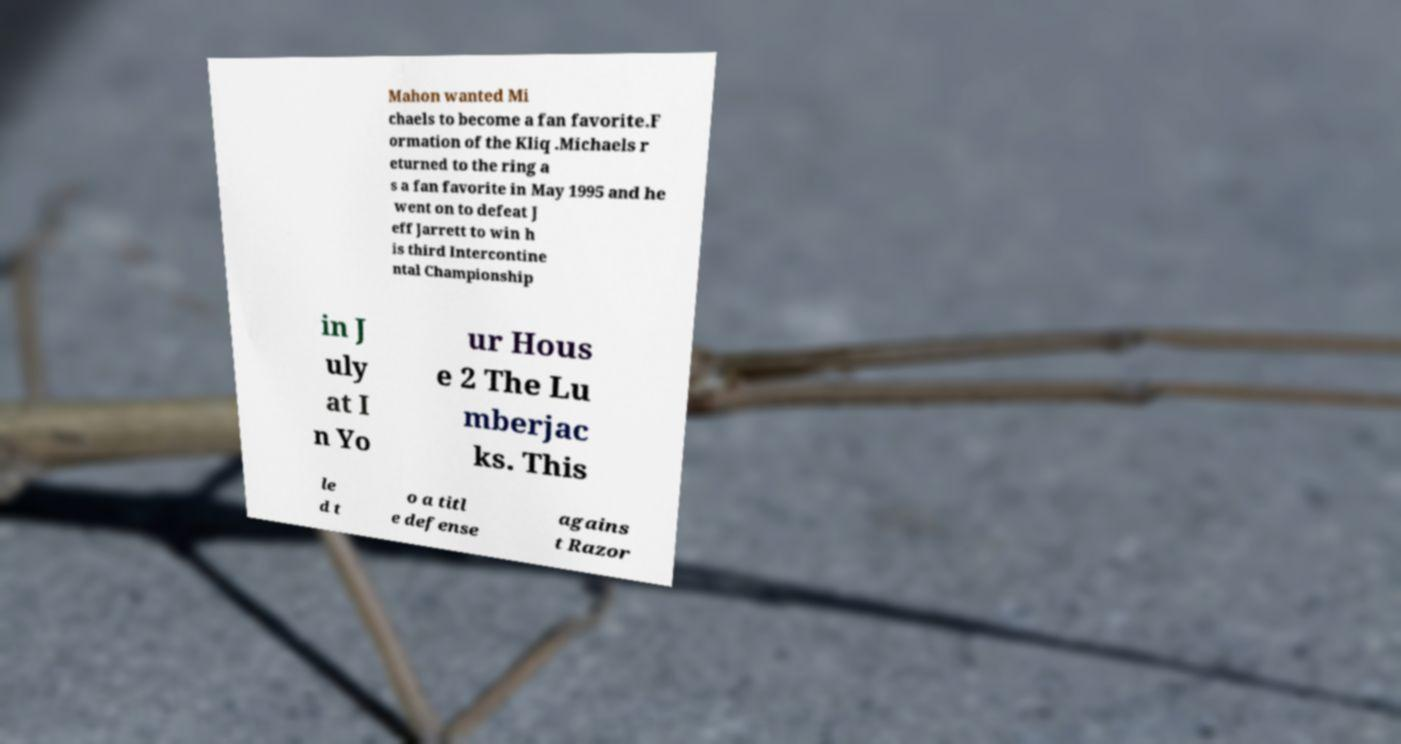Please identify and transcribe the text found in this image. Mahon wanted Mi chaels to become a fan favorite.F ormation of the Kliq .Michaels r eturned to the ring a s a fan favorite in May 1995 and he went on to defeat J eff Jarrett to win h is third Intercontine ntal Championship in J uly at I n Yo ur Hous e 2 The Lu mberjac ks. This le d t o a titl e defense agains t Razor 